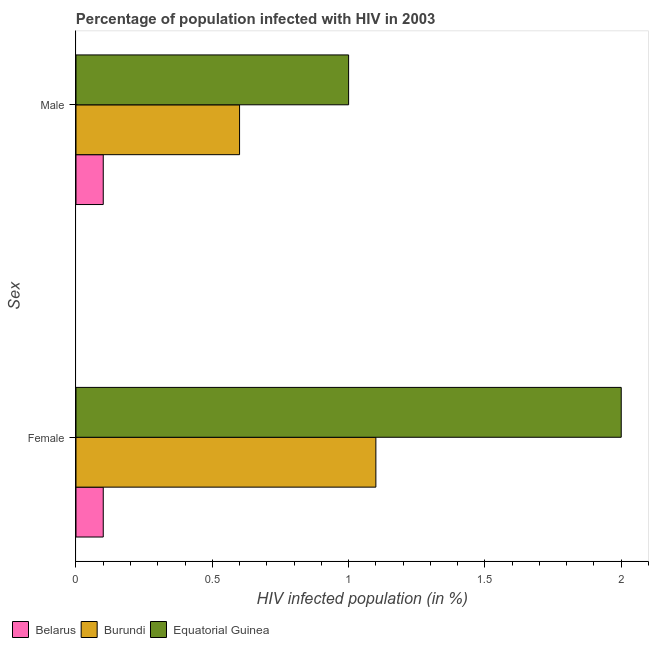Are the number of bars on each tick of the Y-axis equal?
Make the answer very short. Yes. Across all countries, what is the maximum percentage of females who are infected with hiv?
Offer a terse response. 2. In which country was the percentage of males who are infected with hiv maximum?
Your answer should be very brief. Equatorial Guinea. In which country was the percentage of females who are infected with hiv minimum?
Offer a terse response. Belarus. What is the total percentage of males who are infected with hiv in the graph?
Your response must be concise. 1.7. What is the difference between the percentage of females who are infected with hiv in Equatorial Guinea and that in Burundi?
Your answer should be very brief. 0.9. What is the difference between the percentage of males who are infected with hiv in Equatorial Guinea and the percentage of females who are infected with hiv in Belarus?
Make the answer very short. 0.9. What is the average percentage of males who are infected with hiv per country?
Offer a very short reply. 0.57. What is the ratio of the percentage of males who are infected with hiv in Belarus to that in Equatorial Guinea?
Make the answer very short. 0.1. Is the percentage of females who are infected with hiv in Belarus less than that in Burundi?
Keep it short and to the point. Yes. In how many countries, is the percentage of females who are infected with hiv greater than the average percentage of females who are infected with hiv taken over all countries?
Provide a succinct answer. 2. What does the 3rd bar from the top in Female represents?
Make the answer very short. Belarus. What does the 3rd bar from the bottom in Male represents?
Make the answer very short. Equatorial Guinea. How many countries are there in the graph?
Your answer should be very brief. 3. Does the graph contain grids?
Ensure brevity in your answer.  No. What is the title of the graph?
Make the answer very short. Percentage of population infected with HIV in 2003. Does "Sao Tome and Principe" appear as one of the legend labels in the graph?
Your answer should be very brief. No. What is the label or title of the X-axis?
Offer a very short reply. HIV infected population (in %). What is the label or title of the Y-axis?
Your answer should be very brief. Sex. What is the HIV infected population (in %) in Belarus in Female?
Provide a succinct answer. 0.1. What is the HIV infected population (in %) of Burundi in Female?
Give a very brief answer. 1.1. What is the HIV infected population (in %) in Burundi in Male?
Offer a terse response. 0.6. Across all Sex, what is the maximum HIV infected population (in %) in Belarus?
Offer a terse response. 0.1. Across all Sex, what is the minimum HIV infected population (in %) of Belarus?
Your answer should be compact. 0.1. What is the total HIV infected population (in %) of Burundi in the graph?
Give a very brief answer. 1.7. What is the total HIV infected population (in %) of Equatorial Guinea in the graph?
Keep it short and to the point. 3. What is the difference between the HIV infected population (in %) of Equatorial Guinea in Female and that in Male?
Offer a very short reply. 1. What is the difference between the HIV infected population (in %) in Belarus in Female and the HIV infected population (in %) in Burundi in Male?
Offer a very short reply. -0.5. What is the difference between the HIV infected population (in %) in Burundi in Female and the HIV infected population (in %) in Equatorial Guinea in Male?
Keep it short and to the point. 0.1. What is the average HIV infected population (in %) of Belarus per Sex?
Give a very brief answer. 0.1. What is the average HIV infected population (in %) in Burundi per Sex?
Keep it short and to the point. 0.85. What is the difference between the HIV infected population (in %) in Belarus and HIV infected population (in %) in Burundi in Female?
Provide a succinct answer. -1. What is the difference between the HIV infected population (in %) of Belarus and HIV infected population (in %) of Burundi in Male?
Give a very brief answer. -0.5. What is the difference between the HIV infected population (in %) in Belarus and HIV infected population (in %) in Equatorial Guinea in Male?
Offer a very short reply. -0.9. What is the ratio of the HIV infected population (in %) in Burundi in Female to that in Male?
Your answer should be very brief. 1.83. What is the ratio of the HIV infected population (in %) in Equatorial Guinea in Female to that in Male?
Provide a succinct answer. 2. What is the difference between the highest and the second highest HIV infected population (in %) in Belarus?
Your answer should be compact. 0. What is the difference between the highest and the second highest HIV infected population (in %) of Burundi?
Provide a short and direct response. 0.5. What is the difference between the highest and the second highest HIV infected population (in %) in Equatorial Guinea?
Provide a short and direct response. 1. What is the difference between the highest and the lowest HIV infected population (in %) of Burundi?
Your response must be concise. 0.5. What is the difference between the highest and the lowest HIV infected population (in %) of Equatorial Guinea?
Ensure brevity in your answer.  1. 